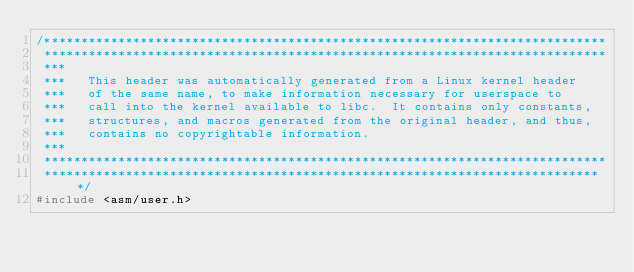Convert code to text. <code><loc_0><loc_0><loc_500><loc_500><_C_>/****************************************************************************
 ****************************************************************************
 ***
 ***   This header was automatically generated from a Linux kernel header
 ***   of the same name, to make information necessary for userspace to
 ***   call into the kernel available to libc.  It contains only constants,
 ***   structures, and macros generated from the original header, and thus,
 ***   contains no copyrightable information.
 ***
 ****************************************************************************
 ****************************************************************************/
#include <asm/user.h>
</code> 